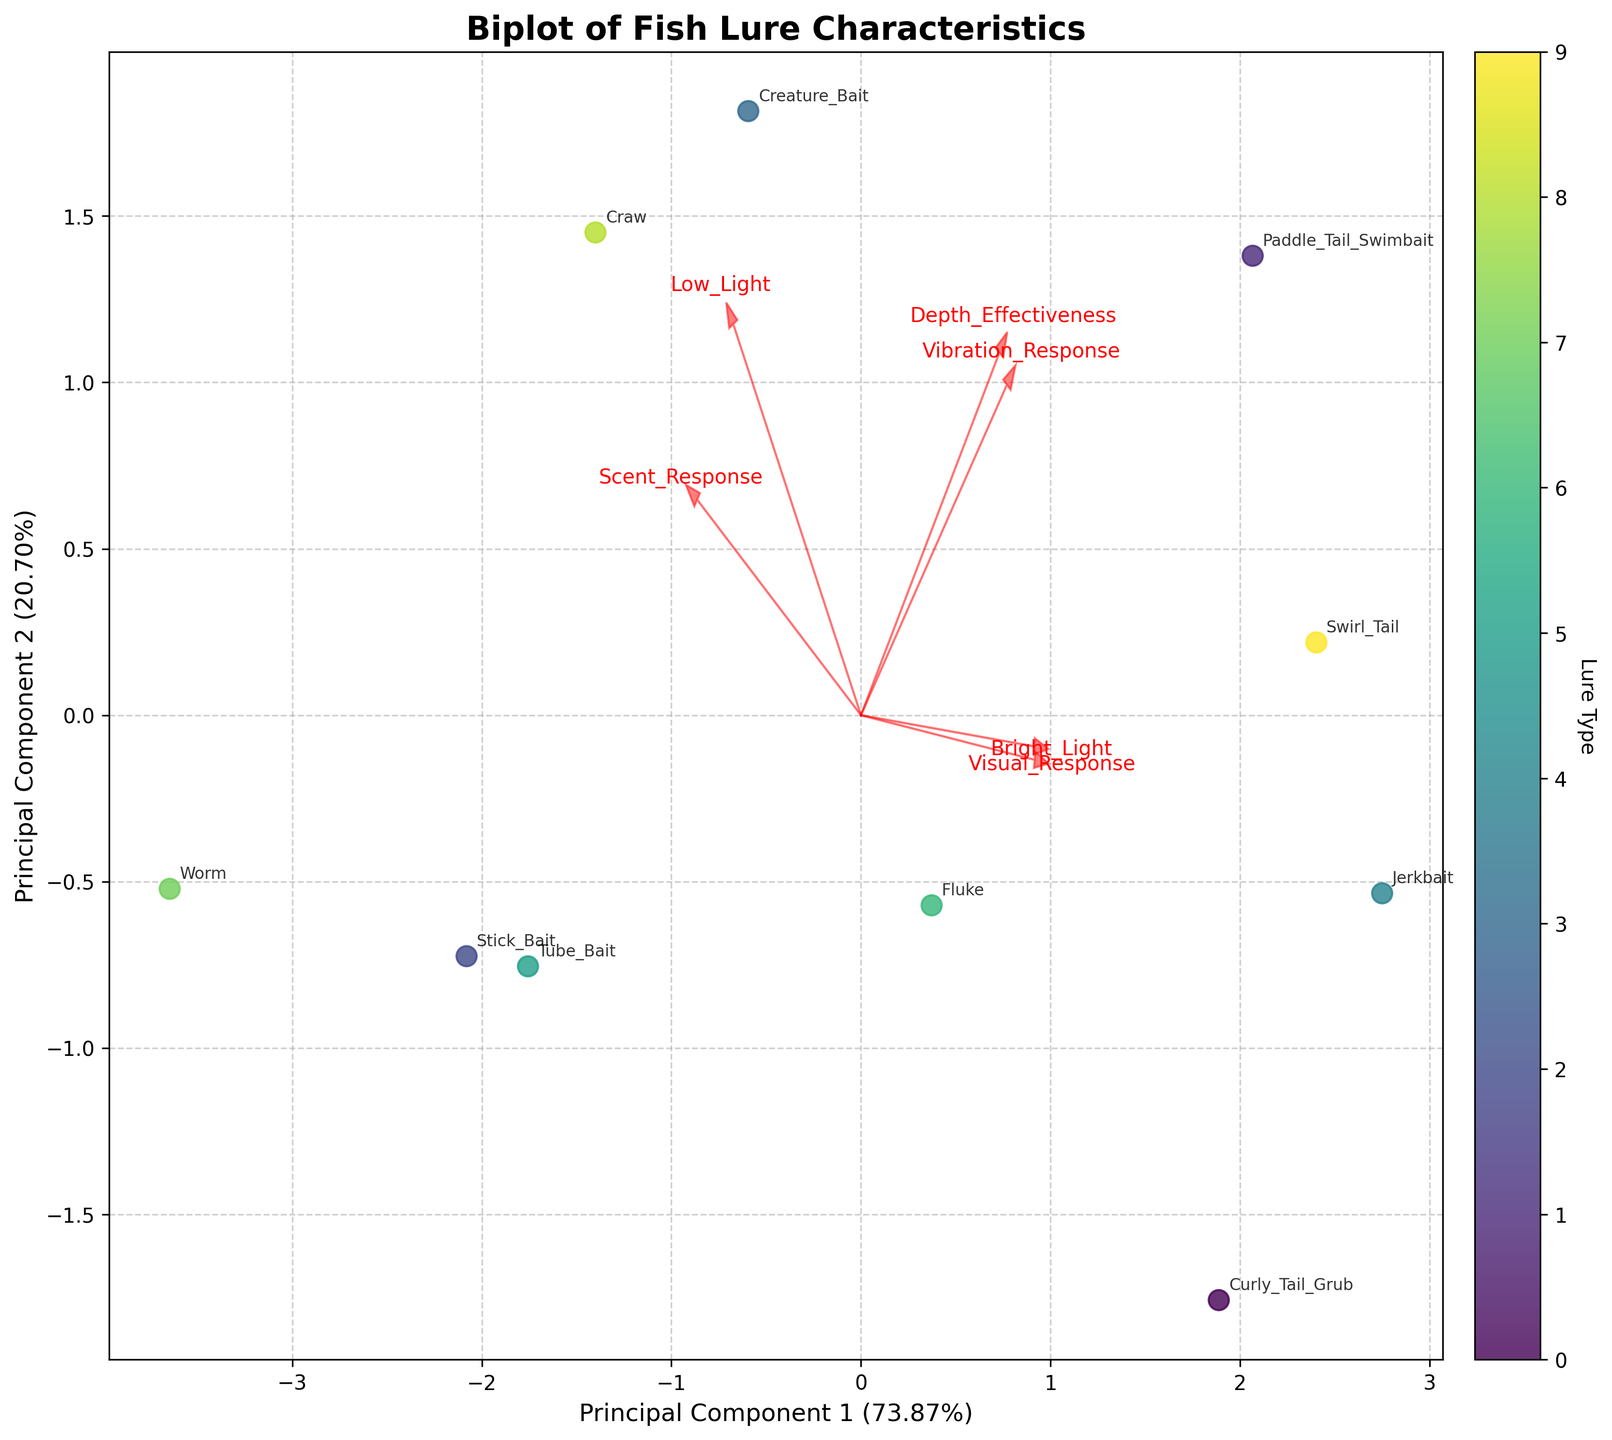What is the title of the biplot? The title is usually at the top of the figure. In this case, it reads, "Biplot of Fish Lure Characteristics".
Answer: Biplot of Fish Lure Characteristics How many principal components are shown in the biplot? The biplot displays Principal Component 1 (PC1) and Principal Component 2 (PC2), which are visible on the x-axis and the y-axis, respectively.
Answer: Two What does the length of the arrows represent in the biplot? The length of the arrows represents the strength and direction of the correlation of each feature with the principal components. Longer arrows indicate stronger correlations.
Answer: Strength of correlation Which lure types are most associated with the 'Vibration Response' feature? Look for the arrow labeled 'Vibration Response' and identify the data points (lures) that are in the same direction and relatively close to the arrow.
Answer: Paddle Tail Swimbait, Jerkbait, Swirl Tail, Creature Bait, Craw Which feature contributes more to Principal Component 1? Examine the arrows and their directions. The feature whose arrow aligns more closely with the horizontal axis contributes more to Principal Component 1.
Answer: Depth Effectiveness Which lure type is closest to the origin of the biplot? Identify the data point that is nearest to the (0, 0) coordinate in the biplot.
Answer: Tube Bait How much variance do the first two principal components explain together? Add the percentages of variance explained by Principal Component 1 and Principal Component 2, displayed on the x and y axes.
Answer: [Sum of PC1 and PC2 percentages, e.g., 68%] In which light condition does 'Curly Tail Grub' perform better? Curly Tail Grub's performance in different light conditions can be inferred from its position relative to the 'Bright Light' and 'Low Light' arrows.
Answer: Bright Light Which lures have a high 'Scent Response'? Find the arrow labeled 'Scent Response' and determine which lure types are in the same quadrant and close to this arrow.
Answer: Creature Bait, Worm, Craw, Stick Bait How are 'Creature Bait' and 'Tube Bait' different in terms of their principal component scores? Compare the positions of 'Creature Bait' and 'Tube Bait' along the x and y axes. Note their relative distances from the origin.
Answer: Creature Bait is higher on PC1 and PC2 